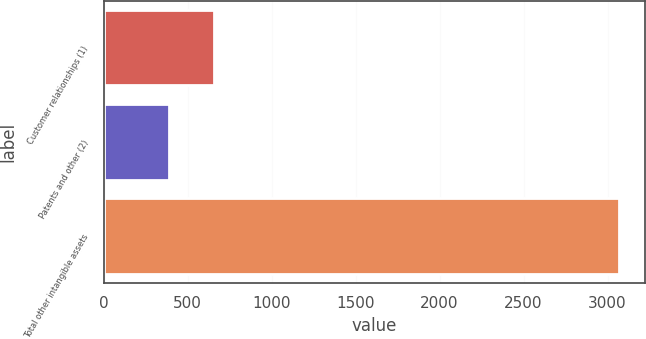Convert chart. <chart><loc_0><loc_0><loc_500><loc_500><bar_chart><fcel>Customer relationships (1)<fcel>Patents and other (2)<fcel>Total other intangible assets<nl><fcel>655<fcel>387<fcel>3067<nl></chart> 